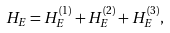Convert formula to latex. <formula><loc_0><loc_0><loc_500><loc_500>H _ { E } = H _ { E } ^ { \left ( 1 \right ) } + H _ { E } ^ { \left ( 2 \right ) } + H _ { E } ^ { \left ( 3 \right ) } ,</formula> 